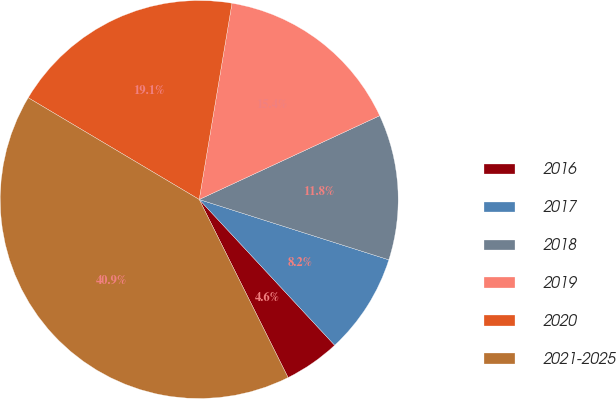Convert chart to OTSL. <chart><loc_0><loc_0><loc_500><loc_500><pie_chart><fcel>2016<fcel>2017<fcel>2018<fcel>2019<fcel>2020<fcel>2021-2025<nl><fcel>4.55%<fcel>8.18%<fcel>11.82%<fcel>15.45%<fcel>19.09%<fcel>40.91%<nl></chart> 